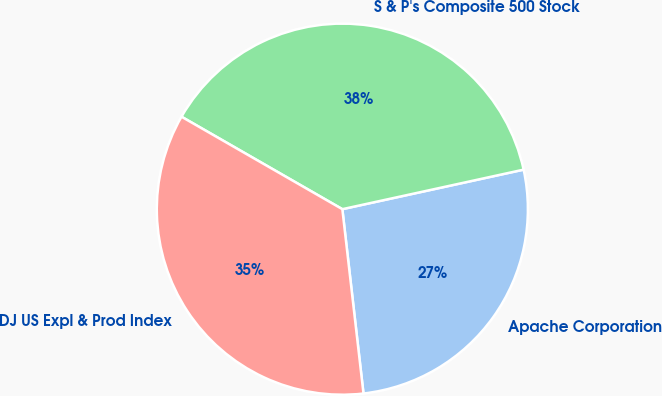Convert chart to OTSL. <chart><loc_0><loc_0><loc_500><loc_500><pie_chart><fcel>Apache Corporation<fcel>S & P's Composite 500 Stock<fcel>DJ US Expl & Prod Index<nl><fcel>26.6%<fcel>38.28%<fcel>35.12%<nl></chart> 